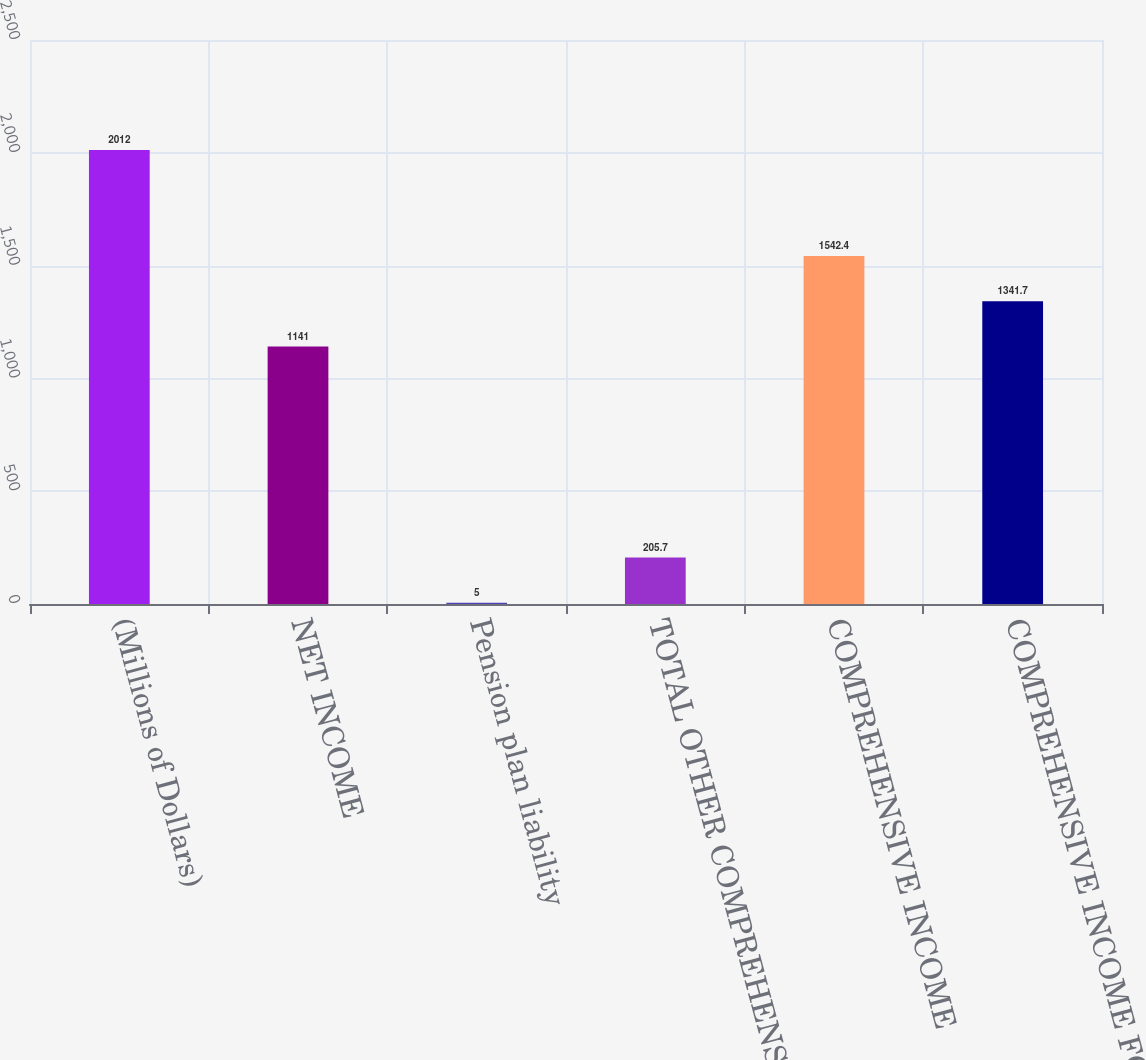<chart> <loc_0><loc_0><loc_500><loc_500><bar_chart><fcel>(Millions of Dollars)<fcel>NET INCOME<fcel>Pension plan liability<fcel>TOTAL OTHER COMPREHENSIVE<fcel>COMPREHENSIVE INCOME<fcel>COMPREHENSIVE INCOME FOR<nl><fcel>2012<fcel>1141<fcel>5<fcel>205.7<fcel>1542.4<fcel>1341.7<nl></chart> 